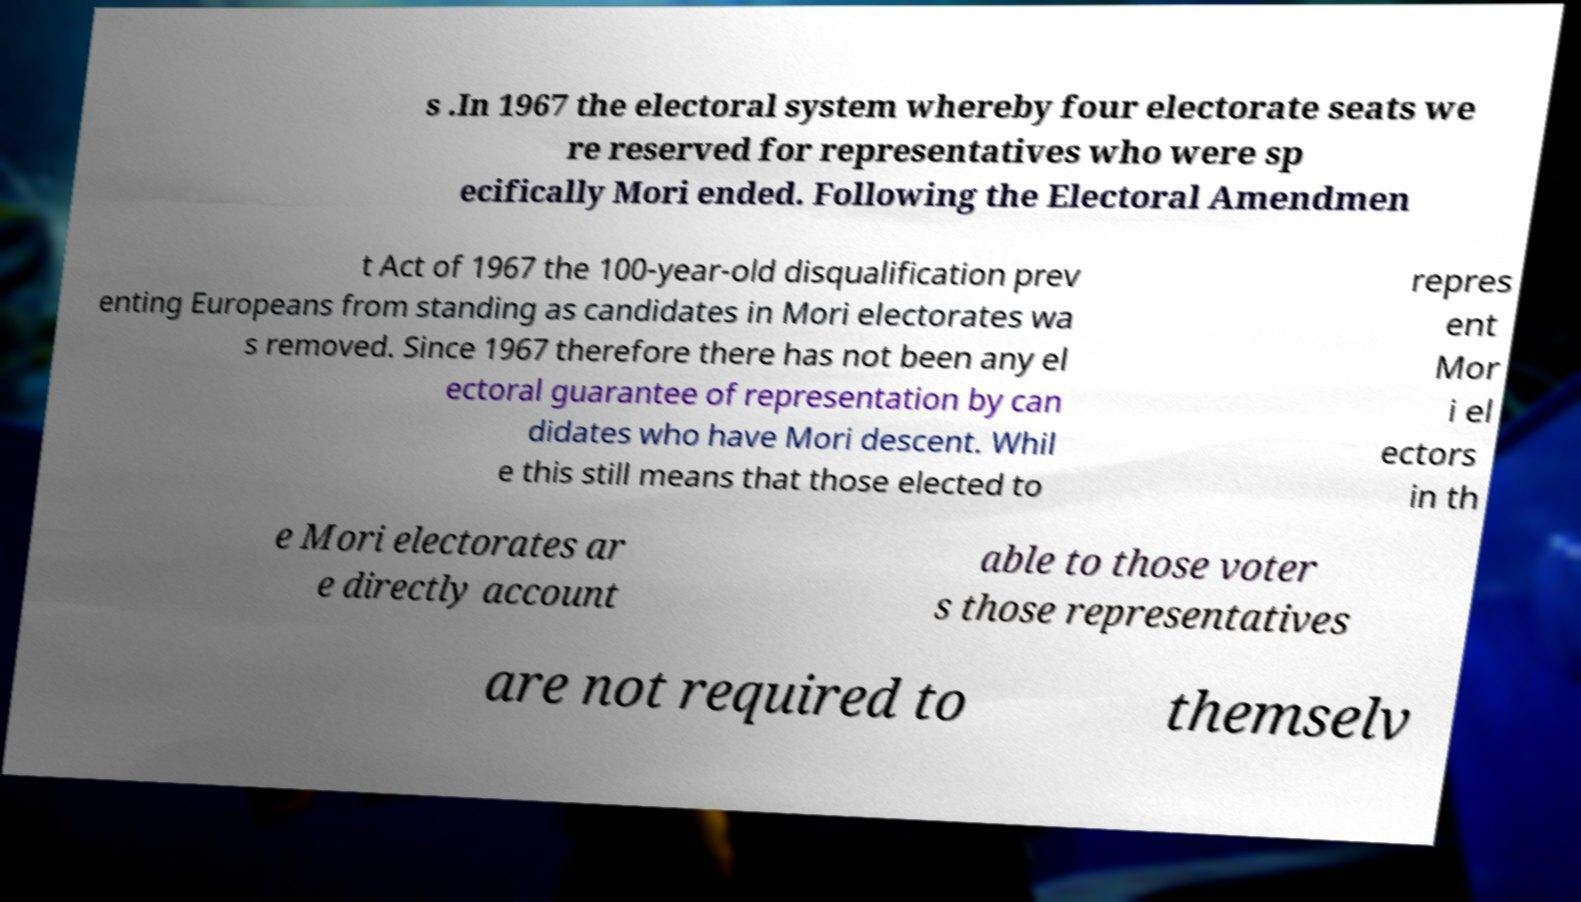For documentation purposes, I need the text within this image transcribed. Could you provide that? s .In 1967 the electoral system whereby four electorate seats we re reserved for representatives who were sp ecifically Mori ended. Following the Electoral Amendmen t Act of 1967 the 100-year-old disqualification prev enting Europeans from standing as candidates in Mori electorates wa s removed. Since 1967 therefore there has not been any el ectoral guarantee of representation by can didates who have Mori descent. Whil e this still means that those elected to repres ent Mor i el ectors in th e Mori electorates ar e directly account able to those voter s those representatives are not required to themselv 